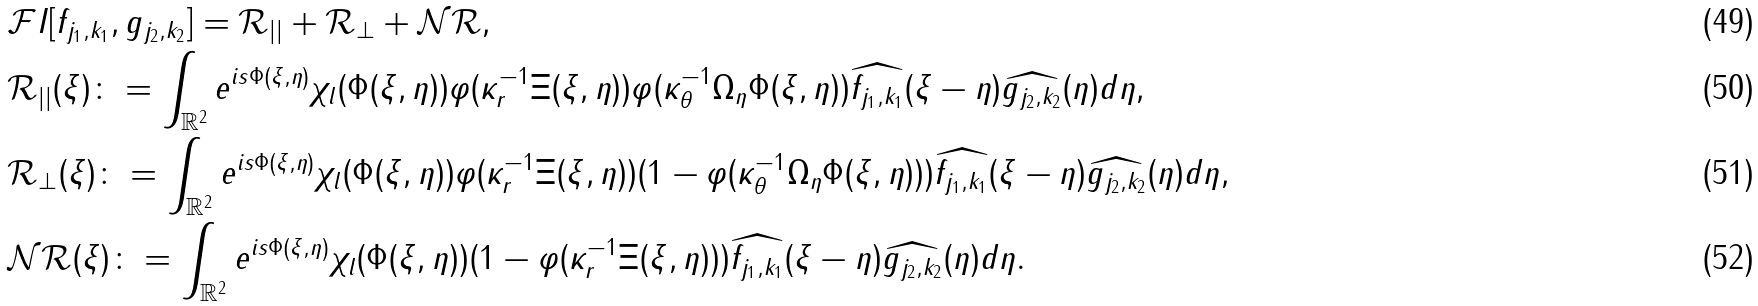<formula> <loc_0><loc_0><loc_500><loc_500>& \mathcal { F } I [ f _ { j _ { 1 } , k _ { 1 } } , g _ { j _ { 2 } , k _ { 2 } } ] = \mathcal { R } _ { | | } + \mathcal { R } _ { \perp } + \mathcal { N R } , \\ & \mathcal { R } _ { | | } ( \xi ) \colon = \int _ { \mathbb { R } ^ { 2 } } e ^ { i s \Phi ( \xi , \eta ) } \chi _ { l } ( \Phi ( \xi , \eta ) ) \varphi ( \kappa _ { r } ^ { - 1 } \Xi ( \xi , \eta ) ) \varphi ( \kappa _ { \theta } ^ { - 1 } \Omega _ { \eta } \Phi ( \xi , \eta ) ) \widehat { f _ { j _ { 1 } , k _ { 1 } } } ( \xi - \eta ) \widehat { g _ { j _ { 2 } , k _ { 2 } } } ( \eta ) d \eta , \\ & \mathcal { R } _ { \perp } ( \xi ) \colon = \int _ { \mathbb { R } ^ { 2 } } e ^ { i s \Phi ( \xi , \eta ) } \chi _ { l } ( \Phi ( \xi , \eta ) ) \varphi ( \kappa _ { r } ^ { - 1 } \Xi ( \xi , \eta ) ) ( 1 - \varphi ( \kappa _ { \theta } ^ { - 1 } \Omega _ { \eta } \Phi ( \xi , \eta ) ) ) \widehat { f _ { j _ { 1 } , k _ { 1 } } } ( \xi - \eta ) \widehat { g _ { j _ { 2 } , k _ { 2 } } } ( \eta ) d \eta , \\ & \mathcal { N R } ( \xi ) \colon = \int _ { \mathbb { R } ^ { 2 } } e ^ { i s \Phi ( \xi , \eta ) } \chi _ { l } ( \Phi ( \xi , \eta ) ) ( 1 - \varphi ( \kappa _ { r } ^ { - 1 } \Xi ( \xi , \eta ) ) ) \widehat { f _ { j _ { 1 } , k _ { 1 } } } ( \xi - \eta ) \widehat { g _ { j _ { 2 } , k _ { 2 } } } ( \eta ) d \eta .</formula> 